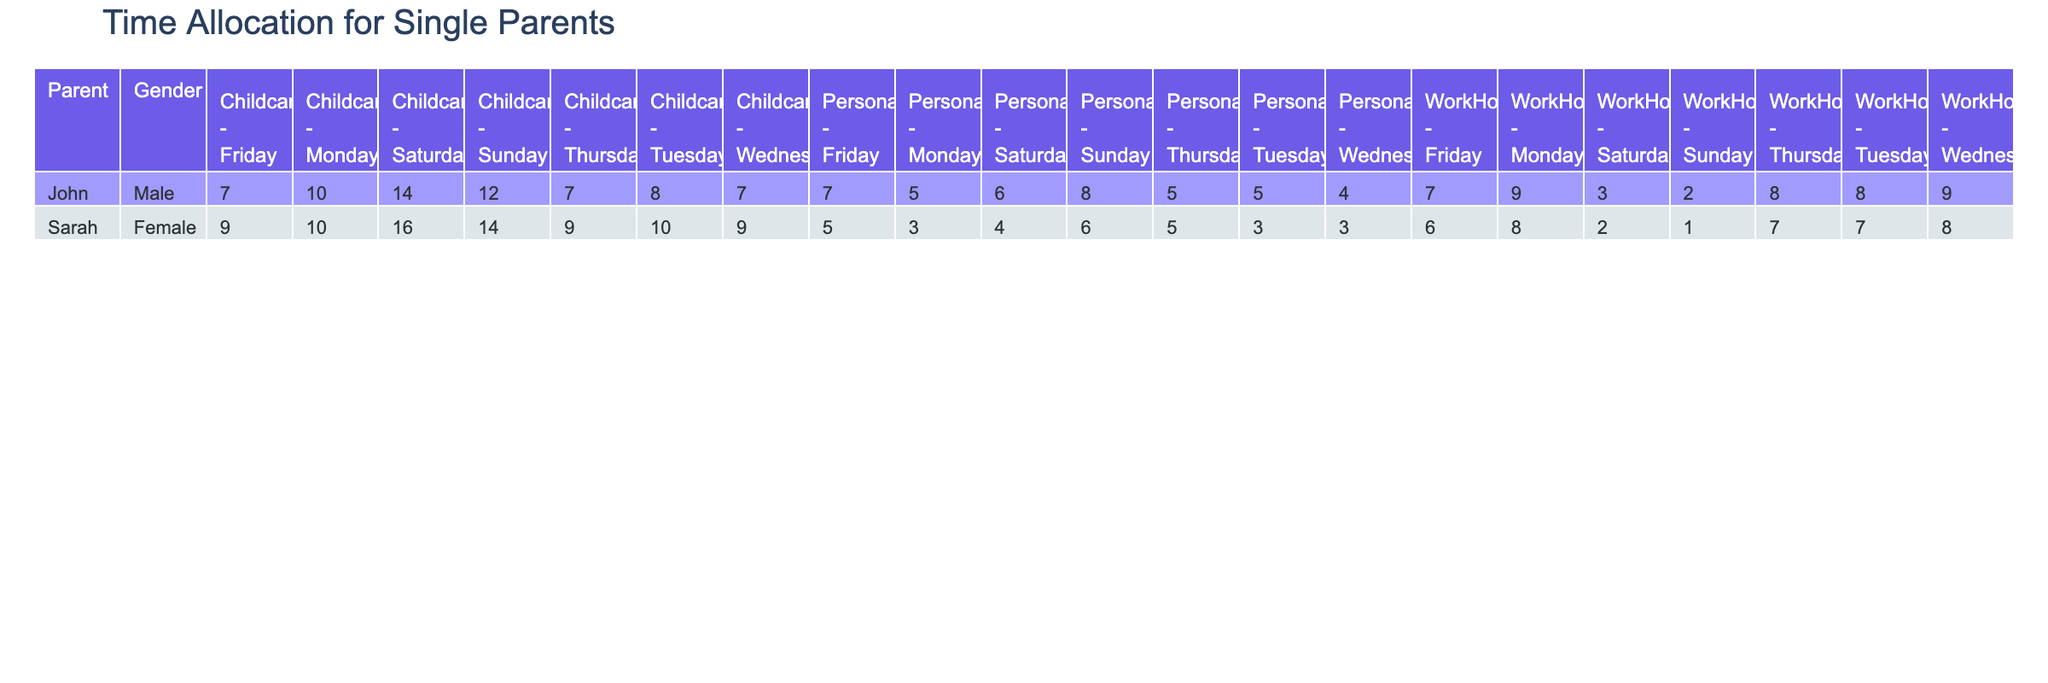What are the total work hours for John on Thursday? In the table under the "WorkHours" column for John on Thursday, the value is 8.
Answer: 8 What is the total amount of childcare hours Sarah has on the weekends (Saturday and Sunday)? For Sarah, on Saturday, the childcare hours are 9, and on Sunday, they are 8. Summing these gives us 9 + 8 = 17.
Answer: 17 Did John have any personal time allocated on Monday? Looking at John’s row for Monday, the "PersonalHours" value is 2. Therefore, he did have personal time allocated.
Answer: Yes Which parent had more total childcare hours throughout the week? First, we sum the childcare hours for John: 4 + 3 + 3 + 5 + 5 + 8 + 6 = 34. For Sarah: 5 + 6 + 4 + 5 + 6 + 9 + 8 = 43. Since 43 (Sarah) > 34 (John), Sarah had more.
Answer: Sarah What is the average personal time for John across all week days? John has personal hours of 2 on Monday, 3 on Tuesday, 2 on Wednesday, 2 on Thursday, 3 on Friday. Adding these gives 2 + 3 + 2 + 2 + 3 = 12. There are 5 data points, so the average is 12 / 5 = 2.4.
Answer: 2.4 On which day did Sarah spend the least amount of personal hours? Reviewing Sarah's personal hours, they are 1 on Monday, 2 on Tuesday, 2 on Wednesday, 3 on Thursday, 2 on Friday. The lowest number is 1, which occurs on Monday.
Answer: Monday How many hours did John allocate to childcare on Friday? Checking John's row for Friday, the "ChildcareHours" column shows a value of 5.
Answer: 5 Which parent spent more time on family activities over the weekend? Examining both parents on Saturday and Sunday, John spent 8 (Saturday) + 6 (Sunday) = 14 on Family Time. Sarah spent 9 (Saturday) + 8 (Sunday) = 17. So Sarah spent more time.
Answer: Sarah 